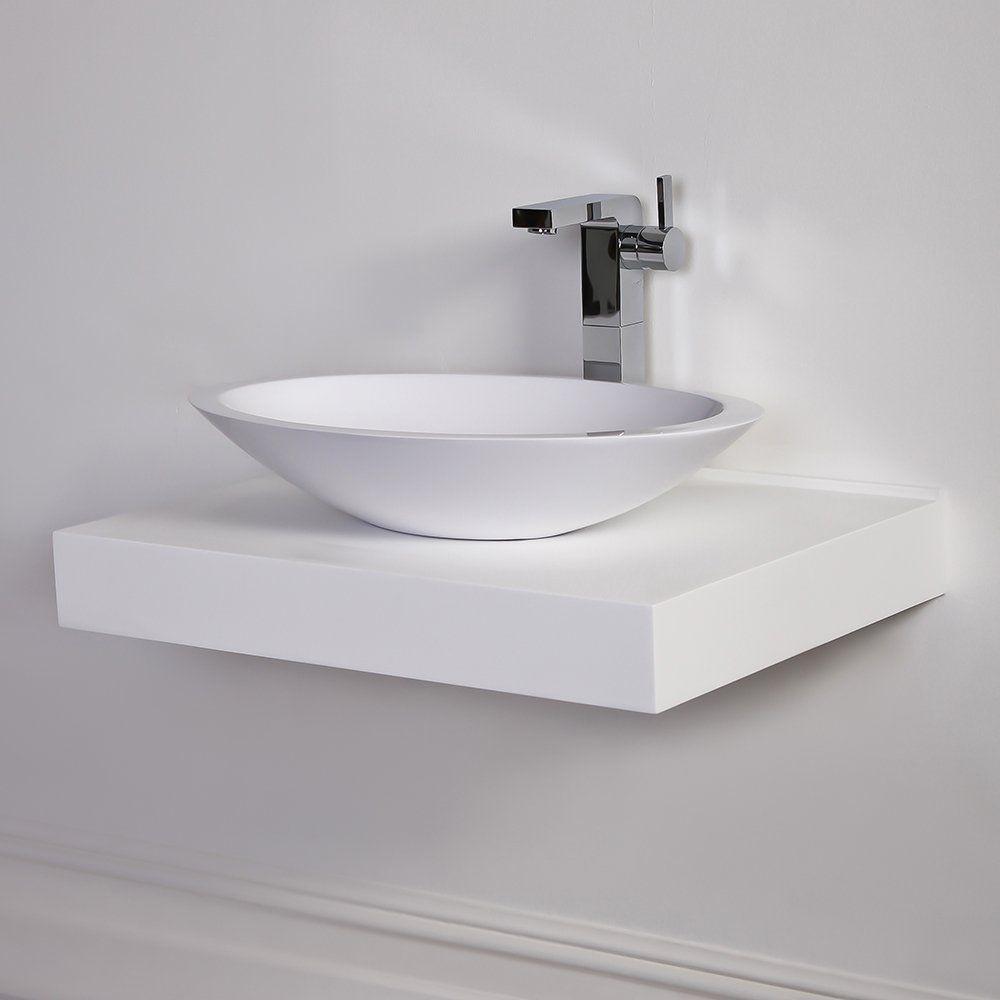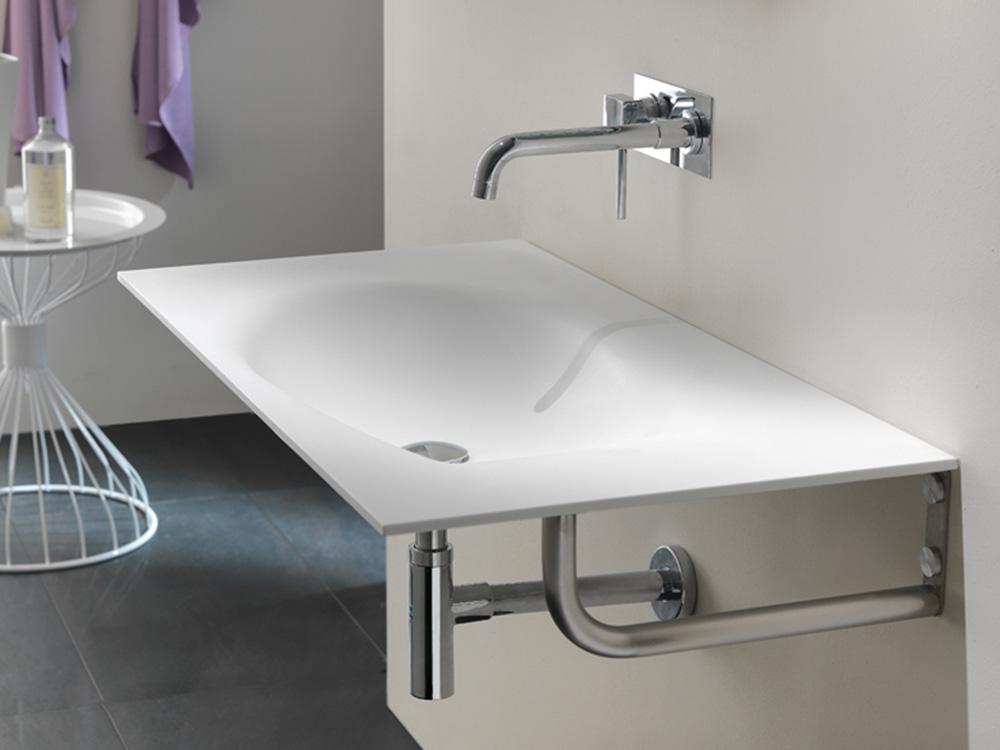The first image is the image on the left, the second image is the image on the right. Given the left and right images, does the statement "Every single sink has a basin in the shape of a bowl." hold true? Answer yes or no. No. The first image is the image on the left, the second image is the image on the right. Given the left and right images, does the statement "In one image a sink and a bathroom floor are seen." hold true? Answer yes or no. Yes. The first image is the image on the left, the second image is the image on the right. For the images displayed, is the sentence "One image shows a wall-mounted rectangular counter with two separate sink and faucet features." factually correct? Answer yes or no. No. The first image is the image on the left, the second image is the image on the right. Given the left and right images, does the statement "There are two basins set in the counter on the right." hold true? Answer yes or no. No. 